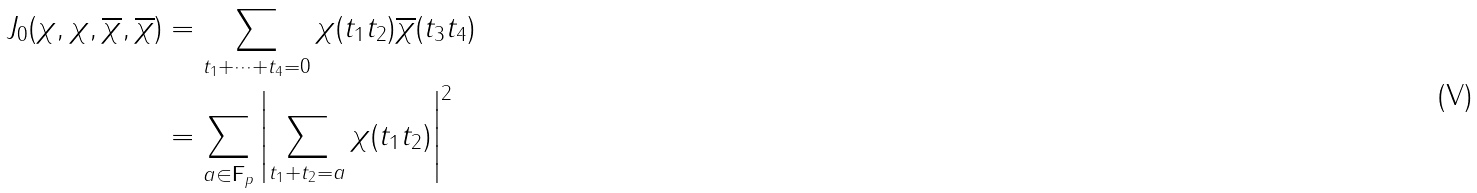<formula> <loc_0><loc_0><loc_500><loc_500>J _ { 0 } ( \chi , \chi , \overline { \chi } , \overline { \chi } ) & = \sum _ { t _ { 1 } + \dots + t _ { 4 } = 0 } \chi ( t _ { 1 } t _ { 2 } ) \overline { \chi } ( t _ { 3 } t _ { 4 } ) \\ & = \sum _ { a \in \mathbf F _ { p } } \left | \sum _ { t _ { 1 } + t _ { 2 } = a } \chi ( t _ { 1 } t _ { 2 } ) \right | ^ { 2 }</formula> 